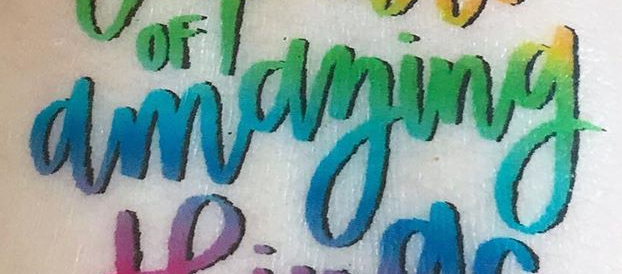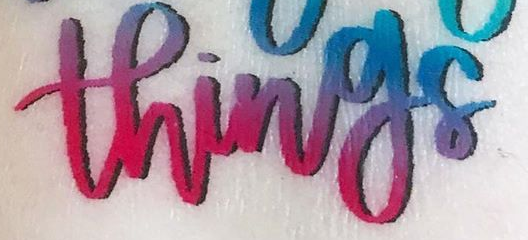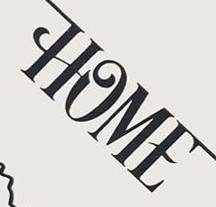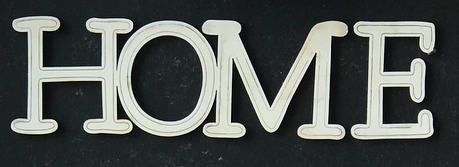What words can you see in these images in sequence, separated by a semicolon? amaying; things; HOME; HOME 